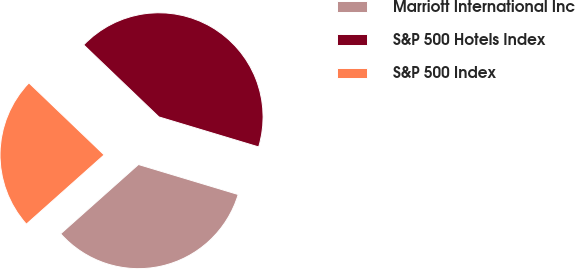Convert chart to OTSL. <chart><loc_0><loc_0><loc_500><loc_500><pie_chart><fcel>Marriott International Inc<fcel>S&P 500 Hotels Index<fcel>S&P 500 Index<nl><fcel>33.77%<fcel>42.5%<fcel>23.73%<nl></chart> 